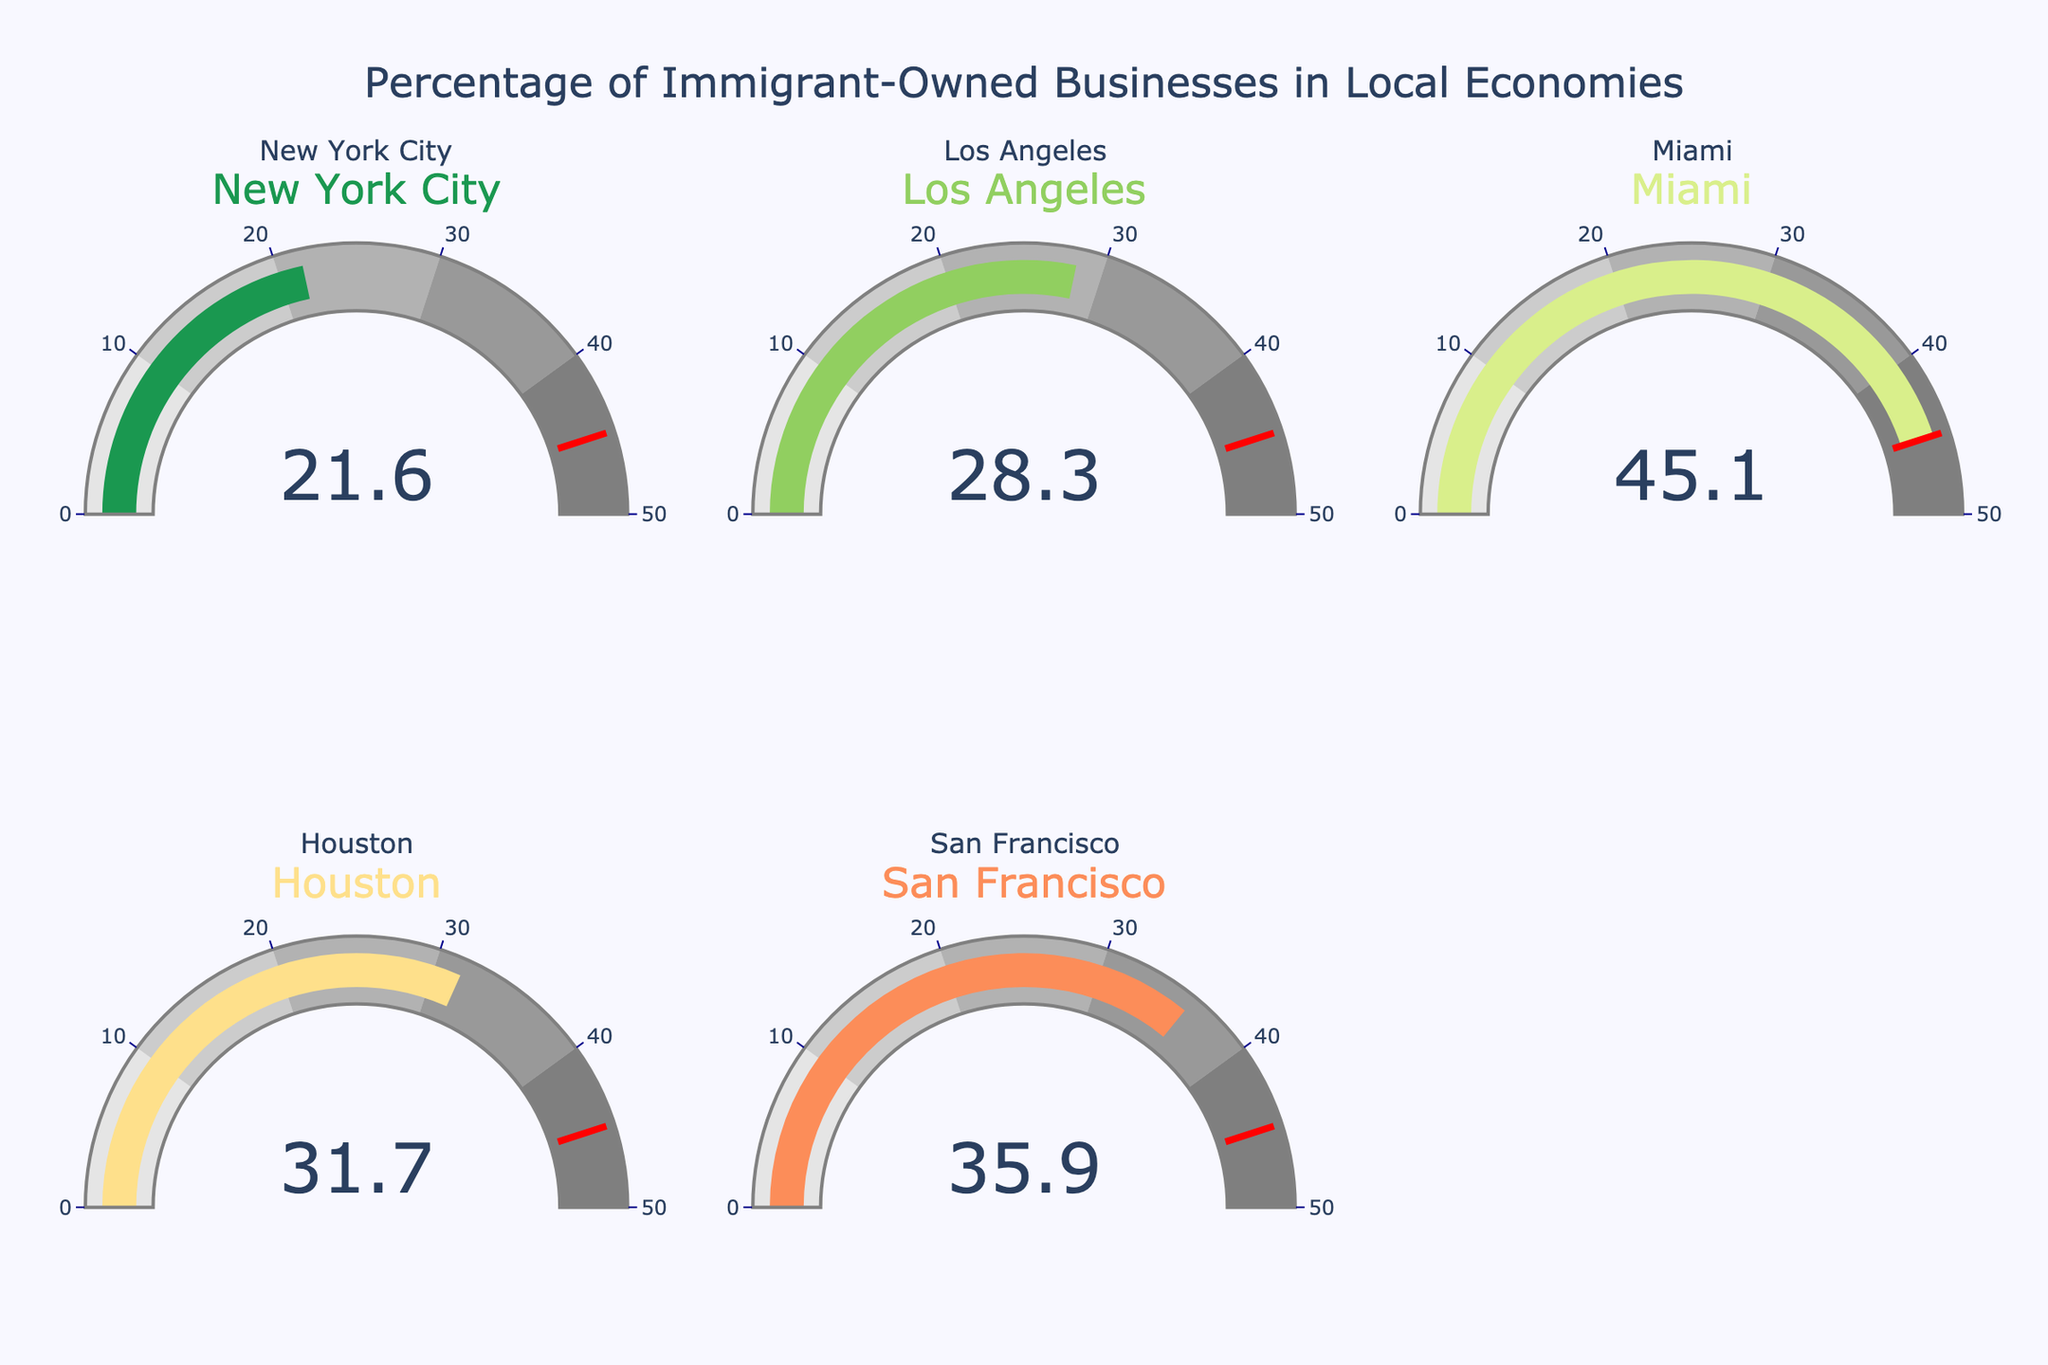What is the percentage of immigrant-owned businesses in New York City? The gauge for New York City shows a reading of 21.6%.
Answer: 21.6% Which city has the highest percentage of immigrant-owned businesses? By comparing all the gauge readings, the highest reading is 45.1% for Miami.
Answer: Miami How many cities have a percentage of immigrant-owned businesses greater than 30%? The cities with percentages greater than 30% are Los Angeles (28.3%), Miami (45.1%), Houston (31.7%), and San Francisco (35.9%).
Answer: 3 What is the average percentage of immigrant-owned businesses across all cities? Adding the percentages: 21.6 + 28.3 + 45.1 + 31.7 + 35.9 = 162.6. Dividing by the number of cities: 162.6 / 5 = 32.52%.
Answer: 32.52% Which city has the lowest percentage of immigrant-owned businesses? By comparing all the gauge readings, the lowest reading is 21.6% for New York City.
Answer: New York City What is the difference in the percentage of immigrant-owned businesses between Miami and San Francisco? Subtracting the smaller percentage from the larger: 45.1 - 35.9 = 9.2%.
Answer: 9.2% Are there any cities with a percentage of immigrant-owned businesses between 40% and 50%? Miami has a percentage of 45.1%, which falls between 40% and 50%.
Answer: Miami How does the percentage of immigrant-owned businesses in Houston compare to that in Los Angeles? Houston has 31.7% and Los Angeles has 28.3%. Comparing these values, Houston's percentage is higher.
Answer: Houston What is the combined percentage of immigrant-owned businesses for New York City and Los Angeles? Adding the percentages: 21.6 + 28.3 = 49.9%.
Answer: 49.9% What percentage of immigrant-owned businesses in San Francisco is greater than that in New York City? Subtracting the smaller percentage from the larger: 35.9 - 21.6 = 14.3%.
Answer: 14.3% 